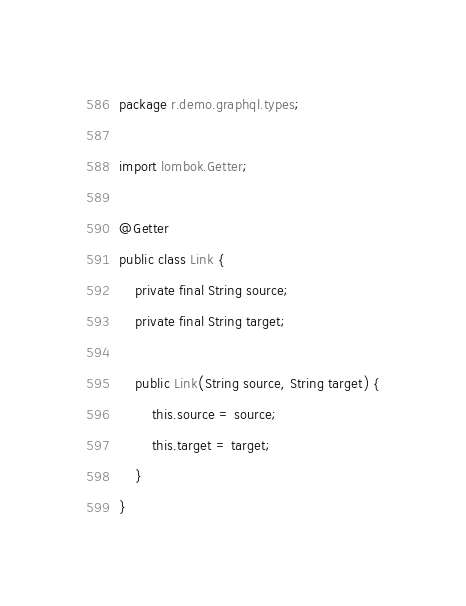<code> <loc_0><loc_0><loc_500><loc_500><_Java_>package r.demo.graphql.types;

import lombok.Getter;

@Getter
public class Link {
    private final String source;
    private final String target;

    public Link(String source, String target) {
        this.source = source;
        this.target = target;
    }
}
</code> 